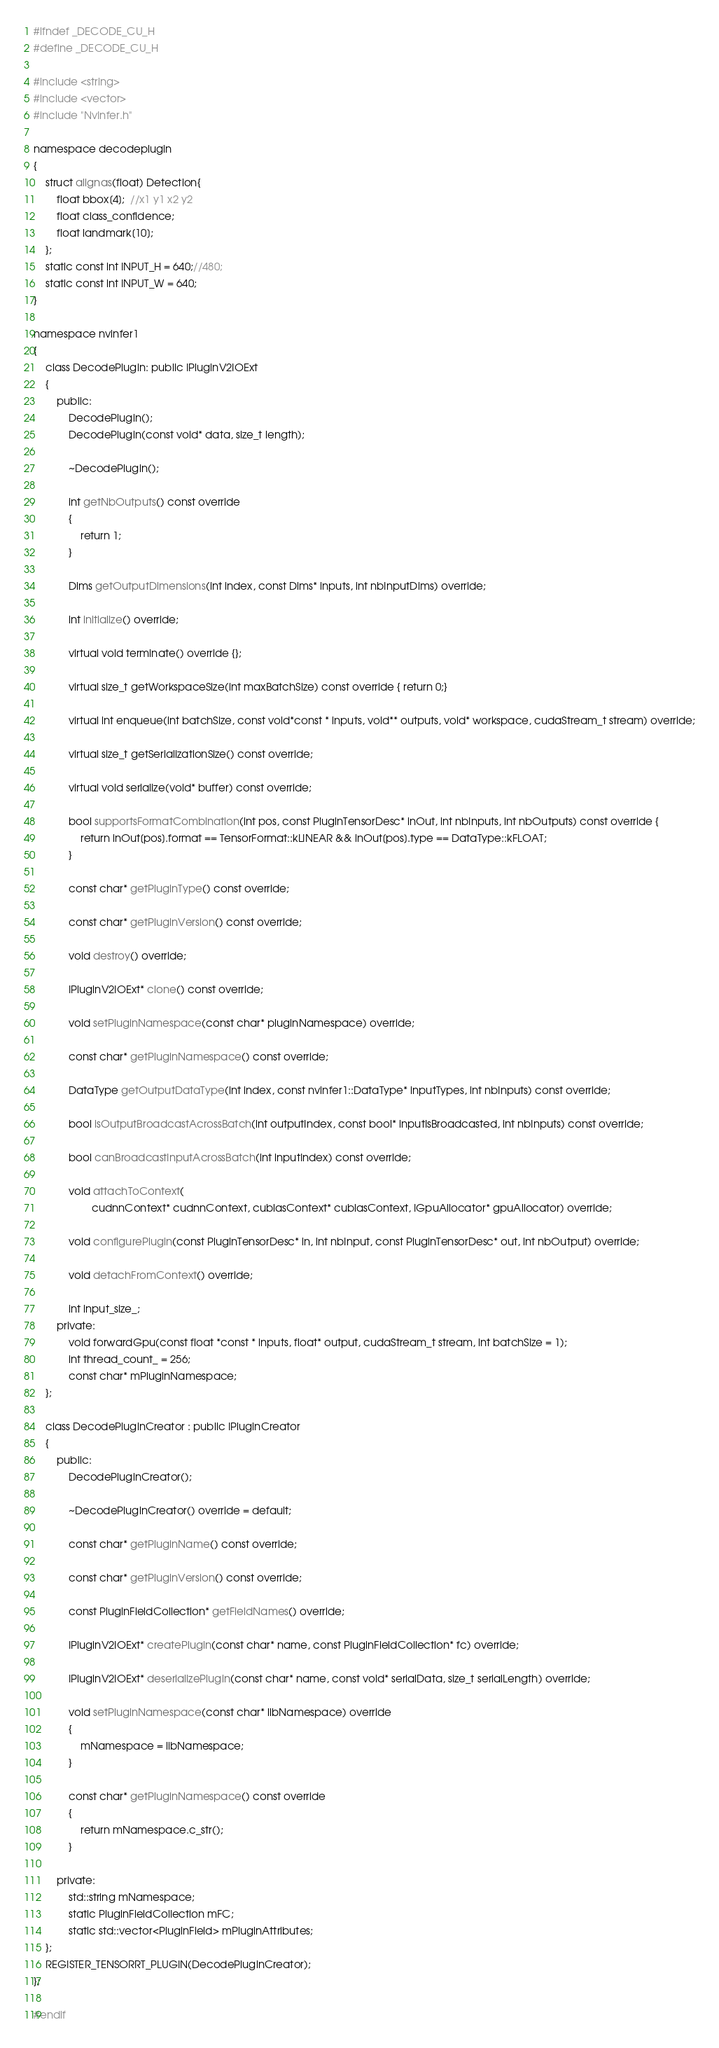Convert code to text. <code><loc_0><loc_0><loc_500><loc_500><_C_>#ifndef _DECODE_CU_H
#define _DECODE_CU_H

#include <string>
#include <vector>
#include "NvInfer.h"

namespace decodeplugin
{
    struct alignas(float) Detection{
        float bbox[4];  //x1 y1 x2 y2
        float class_confidence;
        float landmark[10];
    };
    static const int INPUT_H = 640;//480;
    static const int INPUT_W = 640;
}

namespace nvinfer1
{
    class DecodePlugin: public IPluginV2IOExt
    {
        public:
            DecodePlugin();
            DecodePlugin(const void* data, size_t length);

            ~DecodePlugin();

            int getNbOutputs() const override
            {
                return 1;
            }

            Dims getOutputDimensions(int index, const Dims* inputs, int nbInputDims) override;

            int initialize() override;

            virtual void terminate() override {};

            virtual size_t getWorkspaceSize(int maxBatchSize) const override { return 0;}

            virtual int enqueue(int batchSize, const void*const * inputs, void** outputs, void* workspace, cudaStream_t stream) override;

            virtual size_t getSerializationSize() const override;

            virtual void serialize(void* buffer) const override;

            bool supportsFormatCombination(int pos, const PluginTensorDesc* inOut, int nbInputs, int nbOutputs) const override {
                return inOut[pos].format == TensorFormat::kLINEAR && inOut[pos].type == DataType::kFLOAT;
            }

            const char* getPluginType() const override;

            const char* getPluginVersion() const override;

            void destroy() override;

            IPluginV2IOExt* clone() const override;

            void setPluginNamespace(const char* pluginNamespace) override;

            const char* getPluginNamespace() const override;

            DataType getOutputDataType(int index, const nvinfer1::DataType* inputTypes, int nbInputs) const override;

            bool isOutputBroadcastAcrossBatch(int outputIndex, const bool* inputIsBroadcasted, int nbInputs) const override;

            bool canBroadcastInputAcrossBatch(int inputIndex) const override;

            void attachToContext(
                    cudnnContext* cudnnContext, cublasContext* cublasContext, IGpuAllocator* gpuAllocator) override;

            void configurePlugin(const PluginTensorDesc* in, int nbInput, const PluginTensorDesc* out, int nbOutput) override;

            void detachFromContext() override;

            int input_size_;
        private:
            void forwardGpu(const float *const * inputs, float* output, cudaStream_t stream, int batchSize = 1);
            int thread_count_ = 256;
            const char* mPluginNamespace;
    };

    class DecodePluginCreator : public IPluginCreator
    {
        public:
            DecodePluginCreator();

            ~DecodePluginCreator() override = default;

            const char* getPluginName() const override;

            const char* getPluginVersion() const override;

            const PluginFieldCollection* getFieldNames() override;

            IPluginV2IOExt* createPlugin(const char* name, const PluginFieldCollection* fc) override;

            IPluginV2IOExt* deserializePlugin(const char* name, const void* serialData, size_t serialLength) override;

            void setPluginNamespace(const char* libNamespace) override
            {
                mNamespace = libNamespace;
            }

            const char* getPluginNamespace() const override
            {
                return mNamespace.c_str();
            }

        private:
            std::string mNamespace;
            static PluginFieldCollection mFC;
            static std::vector<PluginField> mPluginAttributes;
    };
    REGISTER_TENSORRT_PLUGIN(DecodePluginCreator);
};

#endif 
</code> 